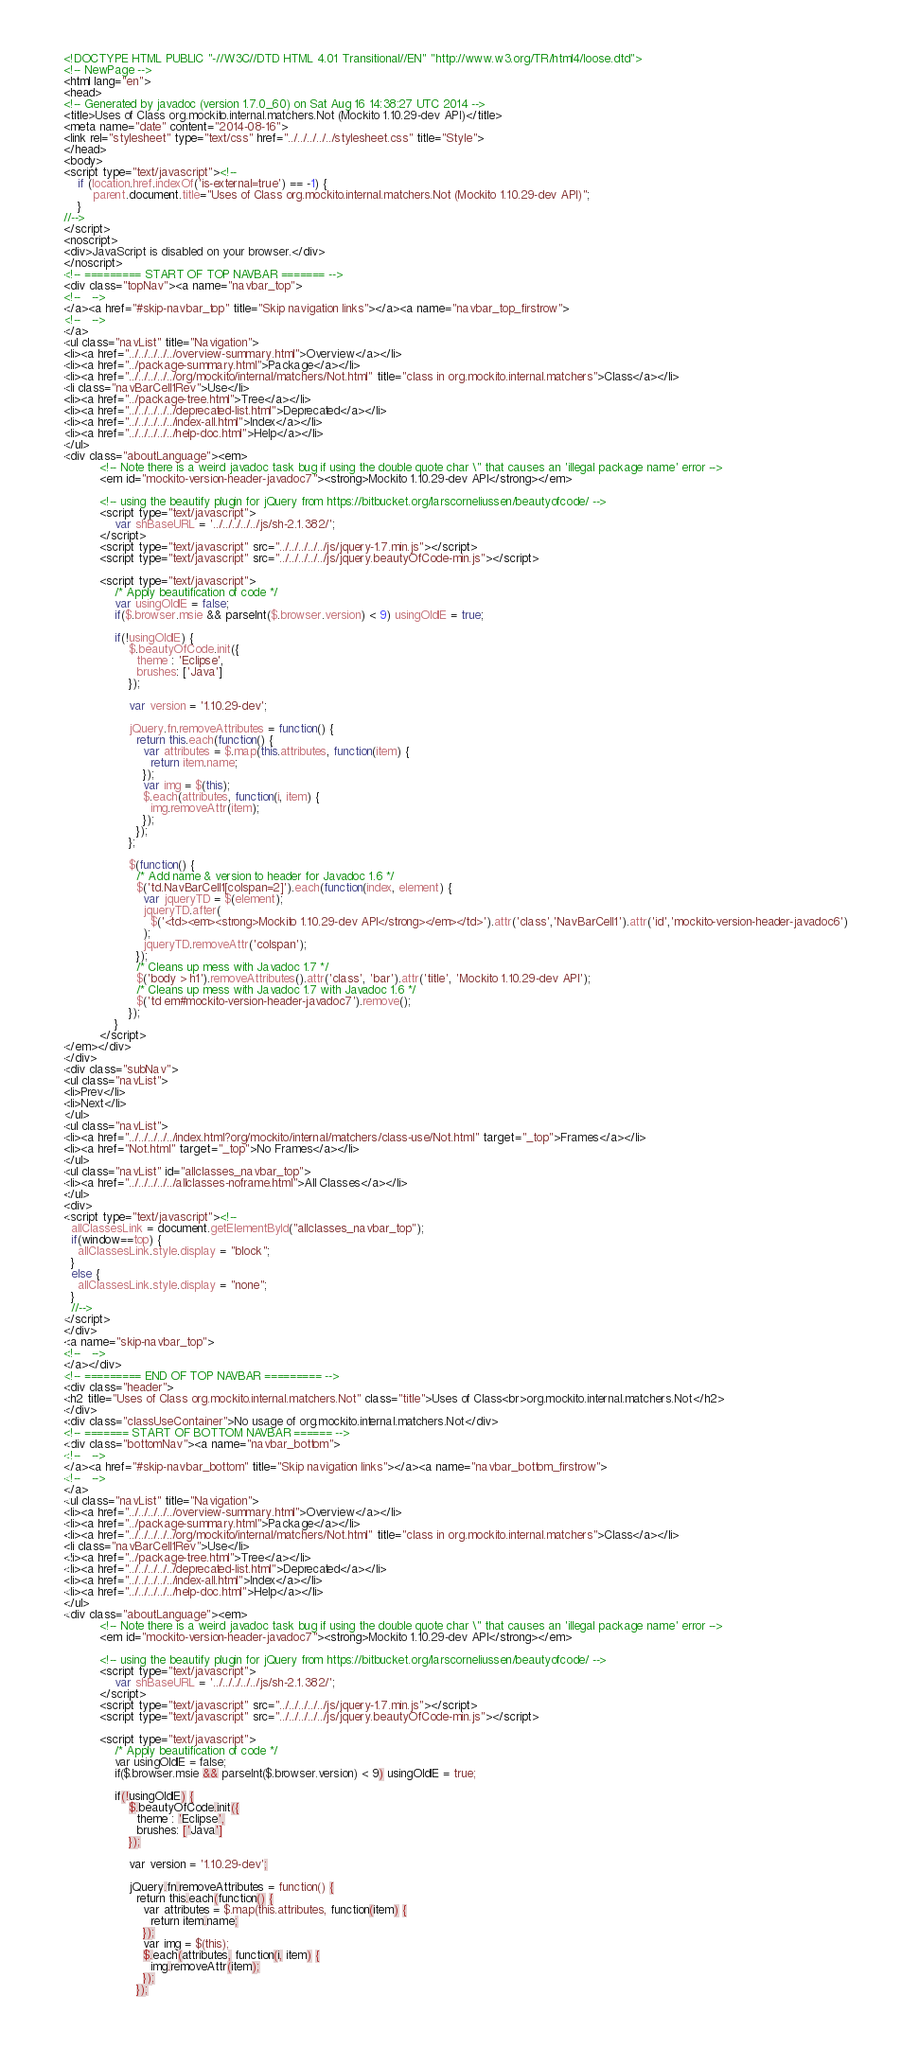<code> <loc_0><loc_0><loc_500><loc_500><_HTML_><!DOCTYPE HTML PUBLIC "-//W3C//DTD HTML 4.01 Transitional//EN" "http://www.w3.org/TR/html4/loose.dtd">
<!-- NewPage -->
<html lang="en">
<head>
<!-- Generated by javadoc (version 1.7.0_60) on Sat Aug 16 14:38:27 UTC 2014 -->
<title>Uses of Class org.mockito.internal.matchers.Not (Mockito 1.10.29-dev API)</title>
<meta name="date" content="2014-08-16">
<link rel="stylesheet" type="text/css" href="../../../../../stylesheet.css" title="Style">
</head>
<body>
<script type="text/javascript"><!--
    if (location.href.indexOf('is-external=true') == -1) {
        parent.document.title="Uses of Class org.mockito.internal.matchers.Not (Mockito 1.10.29-dev API)";
    }
//-->
</script>
<noscript>
<div>JavaScript is disabled on your browser.</div>
</noscript>
<!-- ========= START OF TOP NAVBAR ======= -->
<div class="topNav"><a name="navbar_top">
<!--   -->
</a><a href="#skip-navbar_top" title="Skip navigation links"></a><a name="navbar_top_firstrow">
<!--   -->
</a>
<ul class="navList" title="Navigation">
<li><a href="../../../../../overview-summary.html">Overview</a></li>
<li><a href="../package-summary.html">Package</a></li>
<li><a href="../../../../../org/mockito/internal/matchers/Not.html" title="class in org.mockito.internal.matchers">Class</a></li>
<li class="navBarCell1Rev">Use</li>
<li><a href="../package-tree.html">Tree</a></li>
<li><a href="../../../../../deprecated-list.html">Deprecated</a></li>
<li><a href="../../../../../index-all.html">Index</a></li>
<li><a href="../../../../../help-doc.html">Help</a></li>
</ul>
<div class="aboutLanguage"><em>
          <!-- Note there is a weird javadoc task bug if using the double quote char \" that causes an 'illegal package name' error -->
          <em id="mockito-version-header-javadoc7"><strong>Mockito 1.10.29-dev API</strong></em>

          <!-- using the beautify plugin for jQuery from https://bitbucket.org/larscorneliussen/beautyofcode/ -->
          <script type="text/javascript">
              var shBaseURL = '../../../../../js/sh-2.1.382/';
          </script>
          <script type="text/javascript" src="../../../../../js/jquery-1.7.min.js"></script>
          <script type="text/javascript" src="../../../../../js/jquery.beautyOfCode-min.js"></script>

          <script type="text/javascript">
              /* Apply beautification of code */
              var usingOldIE = false;
              if($.browser.msie && parseInt($.browser.version) < 9) usingOldIE = true;

              if(!usingOldIE) {
                  $.beautyOfCode.init({
                    theme : 'Eclipse',
                    brushes: ['Java']
                  });

                  var version = '1.10.29-dev';

                  jQuery.fn.removeAttributes = function() {
                    return this.each(function() {
                      var attributes = $.map(this.attributes, function(item) {
                        return item.name;
                      });
                      var img = $(this);
                      $.each(attributes, function(i, item) {
                        img.removeAttr(item);
                      });
                    });
                  };

                  $(function() {
                    /* Add name & version to header for Javadoc 1.6 */
                    $('td.NavBarCell1[colspan=2]').each(function(index, element) {
                      var jqueryTD = $(element);
                      jqueryTD.after(
                        $('<td><em><strong>Mockito 1.10.29-dev API</strong></em></td>').attr('class','NavBarCell1').attr('id','mockito-version-header-javadoc6')
                      );
                      jqueryTD.removeAttr('colspan');
                    });
                    /* Cleans up mess with Javadoc 1.7 */
                    $('body > h1').removeAttributes().attr('class', 'bar').attr('title', 'Mockito 1.10.29-dev API');
                    /* Cleans up mess with Javadoc 1.7 with Javadoc 1.6 */
                    $('td em#mockito-version-header-javadoc7').remove();
                  });
              }
          </script>
</em></div>
</div>
<div class="subNav">
<ul class="navList">
<li>Prev</li>
<li>Next</li>
</ul>
<ul class="navList">
<li><a href="../../../../../index.html?org/mockito/internal/matchers/class-use/Not.html" target="_top">Frames</a></li>
<li><a href="Not.html" target="_top">No Frames</a></li>
</ul>
<ul class="navList" id="allclasses_navbar_top">
<li><a href="../../../../../allclasses-noframe.html">All Classes</a></li>
</ul>
<div>
<script type="text/javascript"><!--
  allClassesLink = document.getElementById("allclasses_navbar_top");
  if(window==top) {
    allClassesLink.style.display = "block";
  }
  else {
    allClassesLink.style.display = "none";
  }
  //-->
</script>
</div>
<a name="skip-navbar_top">
<!--   -->
</a></div>
<!-- ========= END OF TOP NAVBAR ========= -->
<div class="header">
<h2 title="Uses of Class org.mockito.internal.matchers.Not" class="title">Uses of Class<br>org.mockito.internal.matchers.Not</h2>
</div>
<div class="classUseContainer">No usage of org.mockito.internal.matchers.Not</div>
<!-- ======= START OF BOTTOM NAVBAR ====== -->
<div class="bottomNav"><a name="navbar_bottom">
<!--   -->
</a><a href="#skip-navbar_bottom" title="Skip navigation links"></a><a name="navbar_bottom_firstrow">
<!--   -->
</a>
<ul class="navList" title="Navigation">
<li><a href="../../../../../overview-summary.html">Overview</a></li>
<li><a href="../package-summary.html">Package</a></li>
<li><a href="../../../../../org/mockito/internal/matchers/Not.html" title="class in org.mockito.internal.matchers">Class</a></li>
<li class="navBarCell1Rev">Use</li>
<li><a href="../package-tree.html">Tree</a></li>
<li><a href="../../../../../deprecated-list.html">Deprecated</a></li>
<li><a href="../../../../../index-all.html">Index</a></li>
<li><a href="../../../../../help-doc.html">Help</a></li>
</ul>
<div class="aboutLanguage"><em>
          <!-- Note there is a weird javadoc task bug if using the double quote char \" that causes an 'illegal package name' error -->
          <em id="mockito-version-header-javadoc7"><strong>Mockito 1.10.29-dev API</strong></em>

          <!-- using the beautify plugin for jQuery from https://bitbucket.org/larscorneliussen/beautyofcode/ -->
          <script type="text/javascript">
              var shBaseURL = '../../../../../js/sh-2.1.382/';
          </script>
          <script type="text/javascript" src="../../../../../js/jquery-1.7.min.js"></script>
          <script type="text/javascript" src="../../../../../js/jquery.beautyOfCode-min.js"></script>

          <script type="text/javascript">
              /* Apply beautification of code */
              var usingOldIE = false;
              if($.browser.msie && parseInt($.browser.version) < 9) usingOldIE = true;

              if(!usingOldIE) {
                  $.beautyOfCode.init({
                    theme : 'Eclipse',
                    brushes: ['Java']
                  });

                  var version = '1.10.29-dev';

                  jQuery.fn.removeAttributes = function() {
                    return this.each(function() {
                      var attributes = $.map(this.attributes, function(item) {
                        return item.name;
                      });
                      var img = $(this);
                      $.each(attributes, function(i, item) {
                        img.removeAttr(item);
                      });
                    });</code> 